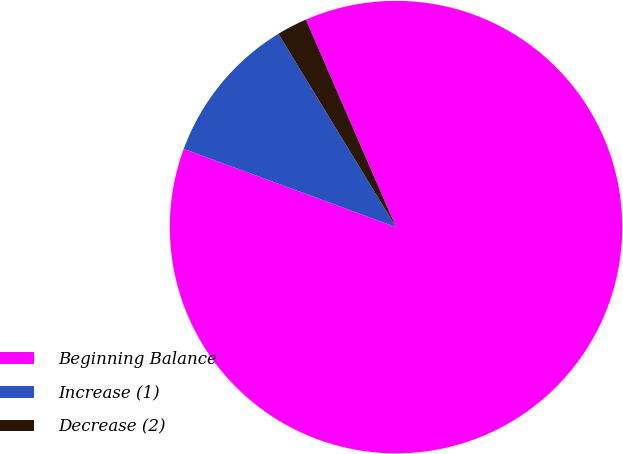Convert chart to OTSL. <chart><loc_0><loc_0><loc_500><loc_500><pie_chart><fcel>Beginning Balance<fcel>Increase (1)<fcel>Decrease (2)<nl><fcel>87.14%<fcel>10.68%<fcel>2.18%<nl></chart> 